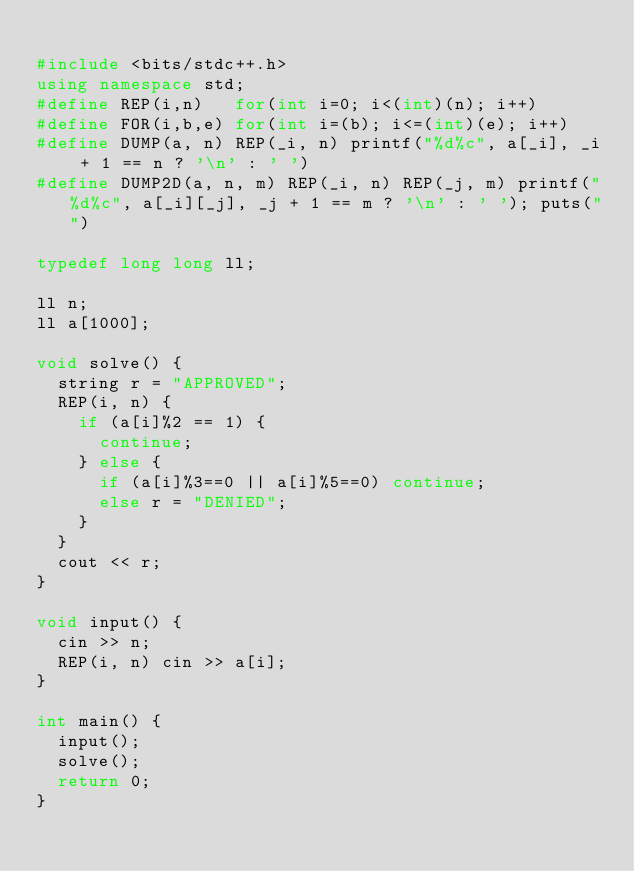<code> <loc_0><loc_0><loc_500><loc_500><_C++_>
#include <bits/stdc++.h>
using namespace std;
#define REP(i,n)   for(int i=0; i<(int)(n); i++)
#define FOR(i,b,e) for(int i=(b); i<=(int)(e); i++)
#define DUMP(a, n) REP(_i, n) printf("%d%c", a[_i], _i + 1 == n ? '\n' : ' ')
#define DUMP2D(a, n, m) REP(_i, n) REP(_j, m) printf("%d%c", a[_i][_j], _j + 1 == m ? '\n' : ' '); puts("")

typedef long long ll;

ll n;
ll a[1000];

void solve() {
  string r = "APPROVED";
  REP(i, n) {
    if (a[i]%2 == 1) {
      continue;
    } else {
      if (a[i]%3==0 || a[i]%5==0) continue;
      else r = "DENIED";
    }
  }
  cout << r;
}

void input() {
  cin >> n;
  REP(i, n) cin >> a[i];
}
 
int main() {
  input();
  solve();
  return 0;
}</code> 